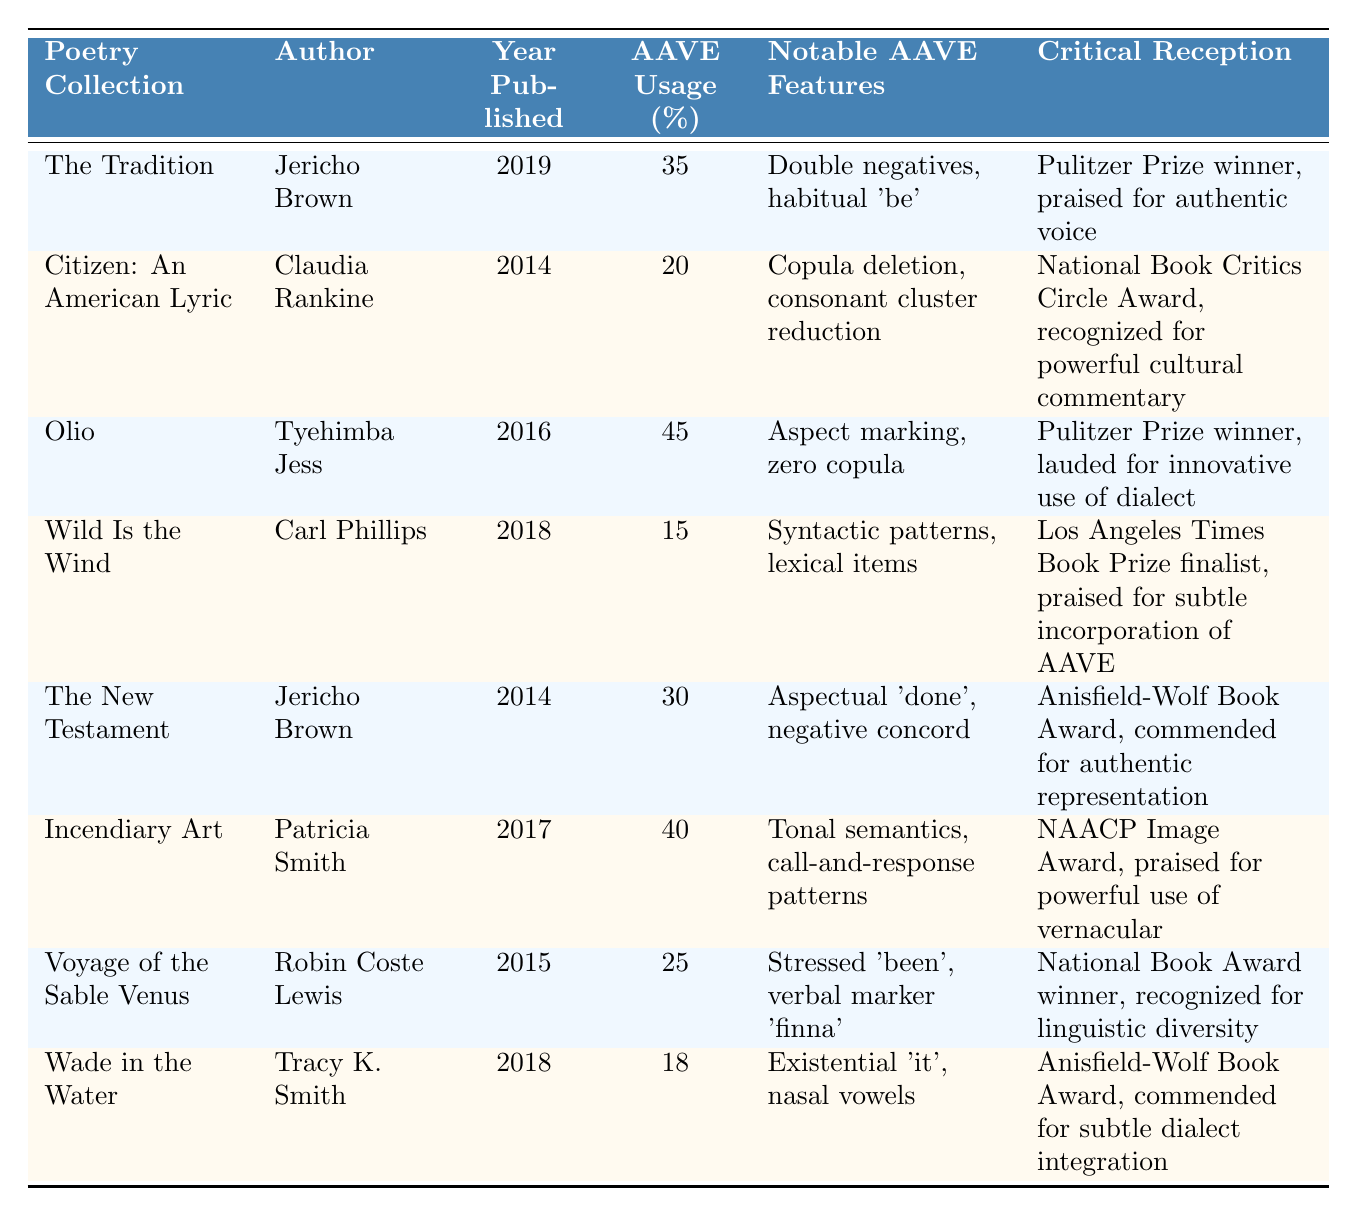What is the poetry collection with the highest percentage of AAVE usage? The table shows that "Olio" by Tyehimba Jess has the highest percentage of AAVE usage at 45%.
Answer: Olio Who is the author of "Citizen: An American Lyric"? According to the table, Claudia Rankine is listed as the author of "Citizen: An American Lyric."
Answer: Claudia Rankine What year was "The Tradition" published? By checking the table, "The Tradition" was published in 2019.
Answer: 2019 Is "Wild Is the Wind" noted for any significant AAVE features? The table indicates that notable AAVE features of "Wild Is the Wind" include syntactic patterns and lexical items.
Answer: Yes What is the average percentage of AAVE usage across all poetry collections listed? The percentages of AAVE usage are 35, 20, 45, 15, 30, 40, 25, and 18. Adding these gives a total of 218, and dividing by 8 collections results in an average of 27.25%.
Answer: 27.25% Which poet has multiple entries in the table, and what are the collections? The table shows that Jericho Brown has two entries: "The Tradition" and "The New Testament."
Answer: Jericho Brown; The Tradition, The New Testament What AAVE feature is associated with "Incendiary Art"? The notable AAVE features associated with "Incendiary Art" include tonal semantics and call-and-response patterns, as noted in the table.
Answer: Tonal semantics, call-and-response patterns Which collection received the National Book Award? The table indicates "Voyage of the Sable Venus" by Robin Coste Lewis received the National Book Award.
Answer: Voyage of the Sable Venus Which poetry collection has the lowest AAVE usage, and what is the percentage? By examining the table, "Wild Is the Wind" has the lowest AAVE usage at 15%.
Answer: Wild Is the Wind; 15% Is it true that all authors listed have received awards for their collections? The table shows that all mentioned authors have received notable awards or recognitions for their works, confirming this fact.
Answer: Yes Who won the Pulitzer Prize for "Olio," and in what year was it published? The table indicates that Tyehimba Jess won the Pulitzer Prize for "Olio," which was published in 2016.
Answer: Tyehimba Jess; 2016 